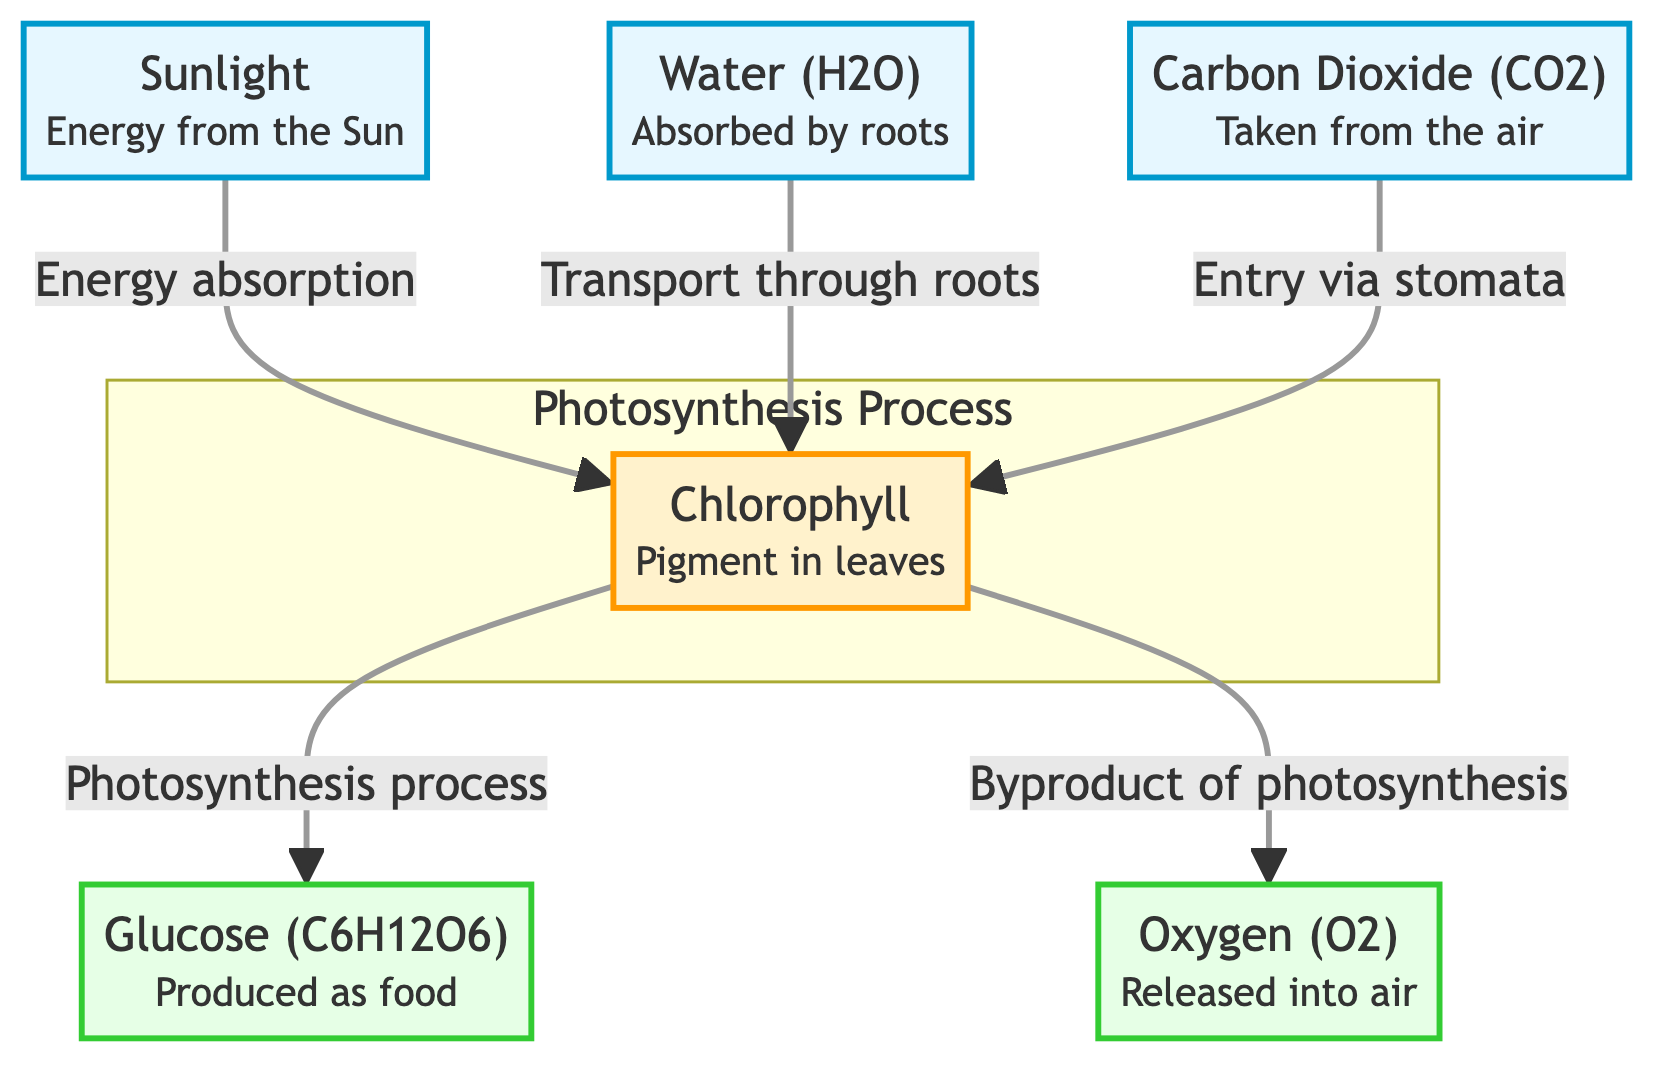What are the inputs in the photosynthesis process? The diagram lists three inputs: sunlight, water, and carbon dioxide. Each of them is identified at the top of the flowchart.
Answer: Sunlight, Water, Carbon Dioxide How many outputs are shown in the diagram? The diagram displays two outputs: glucose and oxygen. Both are indicated at the end of the flowchart.
Answer: Two Which pigment is involved in the process? The diagram specifically names chlorophyll as the pigment that plays a crucial role in photosynthesis.
Answer: Chlorophyll What is the byproduct of photosynthesis? The diagram indicates that oxygen is released as a byproduct during the photosynthesis process.
Answer: Oxygen How does carbon dioxide enter the plant? The diagram states that carbon dioxide enters the plant through stomata, as illustrated in the connection from carbon dioxide to chlorophyll.
Answer: Stomata What connects sunlight, water, and carbon dioxide to chlorophyll? Each of these inputs—sunlight, water, and carbon dioxide—connects to chlorophyll with specific processes shown as arrows labeled with their respective transport mechanisms (energy absorption, transport through roots, entry via stomata). Combined, these inputs lead to chlorophyll's role in photosynthesis.
Answer: Energy absorption, Transport through roots, Entry via stomata What role does chlorophyll play in the process? Chlorophyll is key to the photosynthesis process, as shown in the diagram; it absorbs sunlight and facilitates the transformation of inputs into glucose and oxygen. It is indicated as the main processing node in the flowchart.
Answer: Photosynthesis process How is glucose produced from the inputs? The process starts with sunlight, water, and carbon dioxide entering chlorophyll, where the photosynthesis mechanism occurs. This leads directly to the production of glucose, as depicted in the flow of the diagram.
Answer: Photosynthesis process What happens to the sunlight in the photosynthesis process? According to the diagram, sunlight is absorbed by chlorophyll, facilitating the subsequent reactions that lead to glucose and oxygen production.
Answer: Energy absorption 